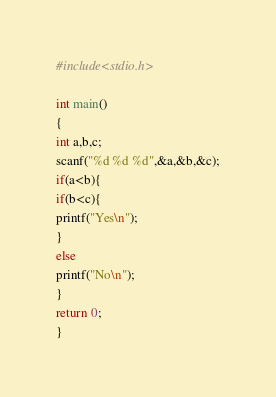Convert code to text. <code><loc_0><loc_0><loc_500><loc_500><_C_>#include<stdio.h>

int main()
{
int a,b,c;
scanf("%d %d %d",&a,&b,&c);
if(a<b){
if(b<c){
printf("Yes\n");
}
else
printf("No\n");
}
return 0;
}</code> 